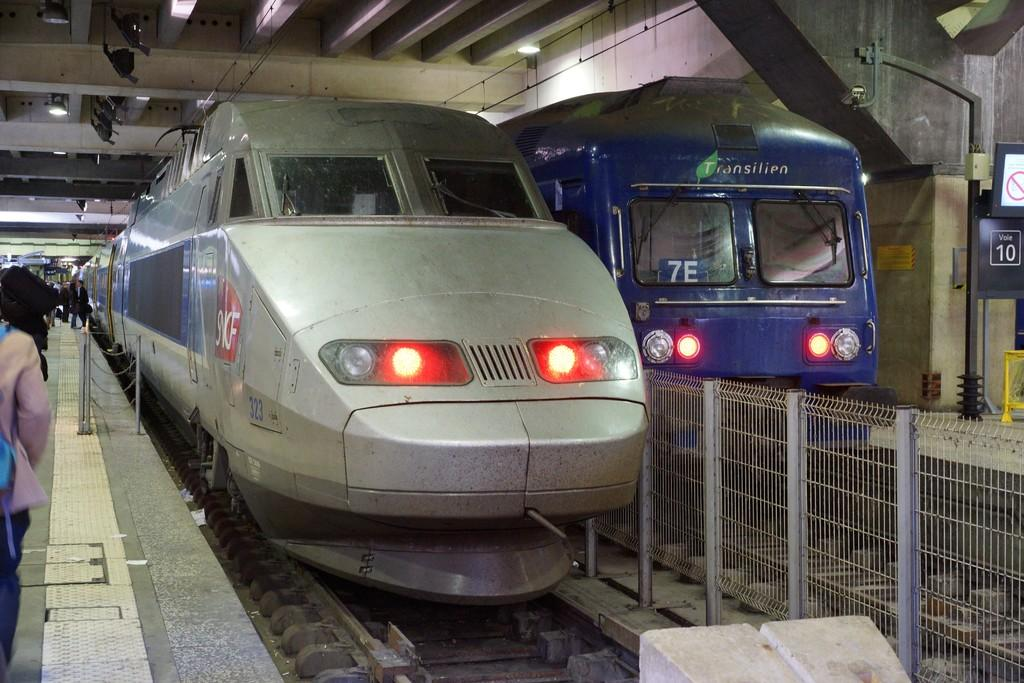<image>
Describe the image concisely. Blue train parked that says 7E on the window. 